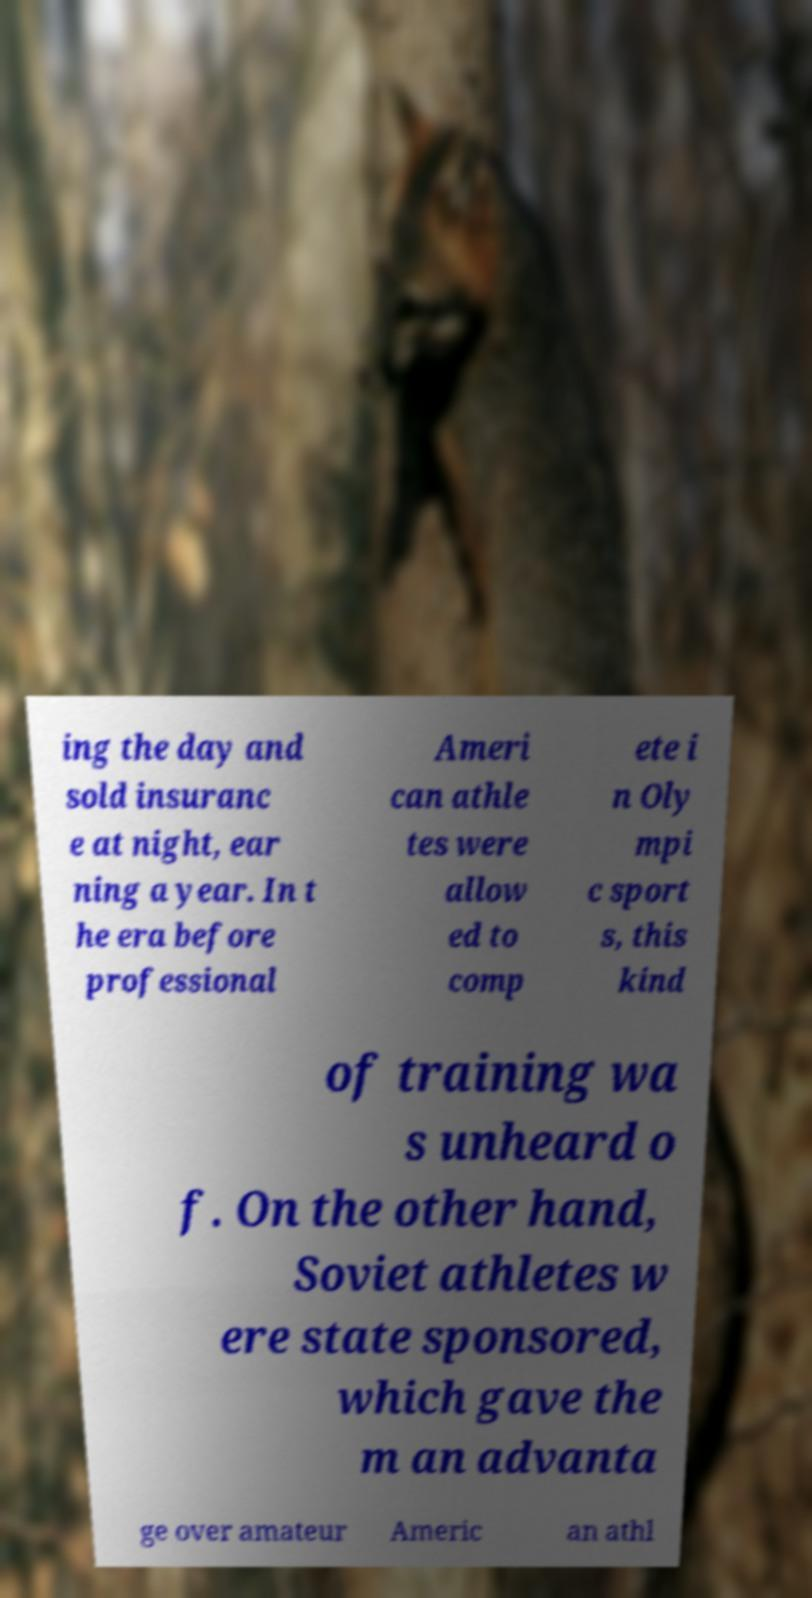There's text embedded in this image that I need extracted. Can you transcribe it verbatim? ing the day and sold insuranc e at night, ear ning a year. In t he era before professional Ameri can athle tes were allow ed to comp ete i n Oly mpi c sport s, this kind of training wa s unheard o f. On the other hand, Soviet athletes w ere state sponsored, which gave the m an advanta ge over amateur Americ an athl 